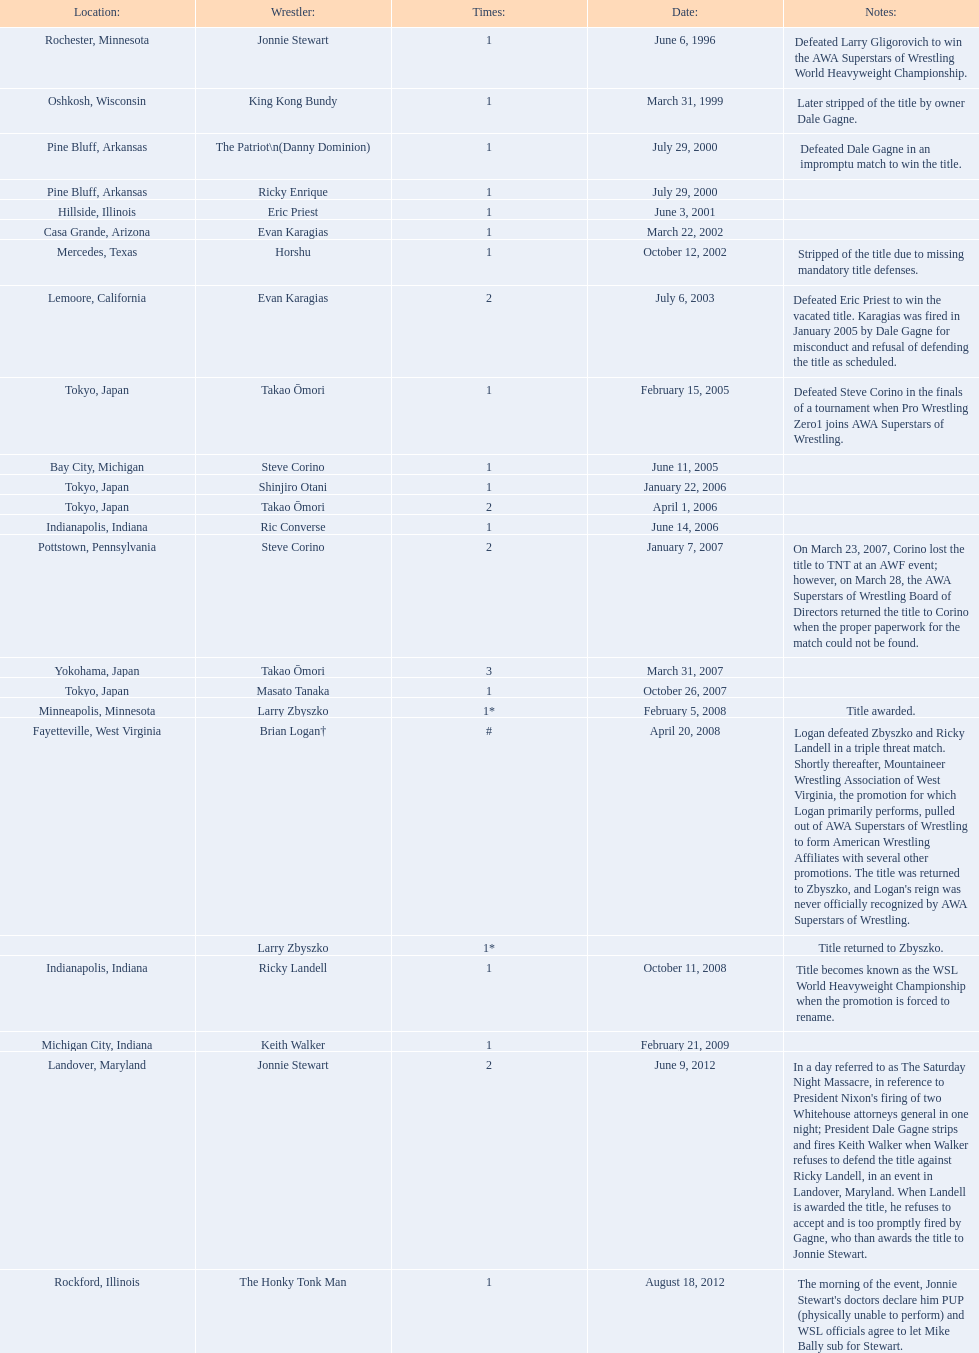Where are the title holders from? Rochester, Minnesota, Oshkosh, Wisconsin, Pine Bluff, Arkansas, Pine Bluff, Arkansas, Hillside, Illinois, Casa Grande, Arizona, Mercedes, Texas, Lemoore, California, Tokyo, Japan, Bay City, Michigan, Tokyo, Japan, Tokyo, Japan, Indianapolis, Indiana, Pottstown, Pennsylvania, Yokohama, Japan, Tokyo, Japan, Minneapolis, Minnesota, Fayetteville, West Virginia, , Indianapolis, Indiana, Michigan City, Indiana, Landover, Maryland, Rockford, Illinois. Who is the title holder from texas? Horshu. 